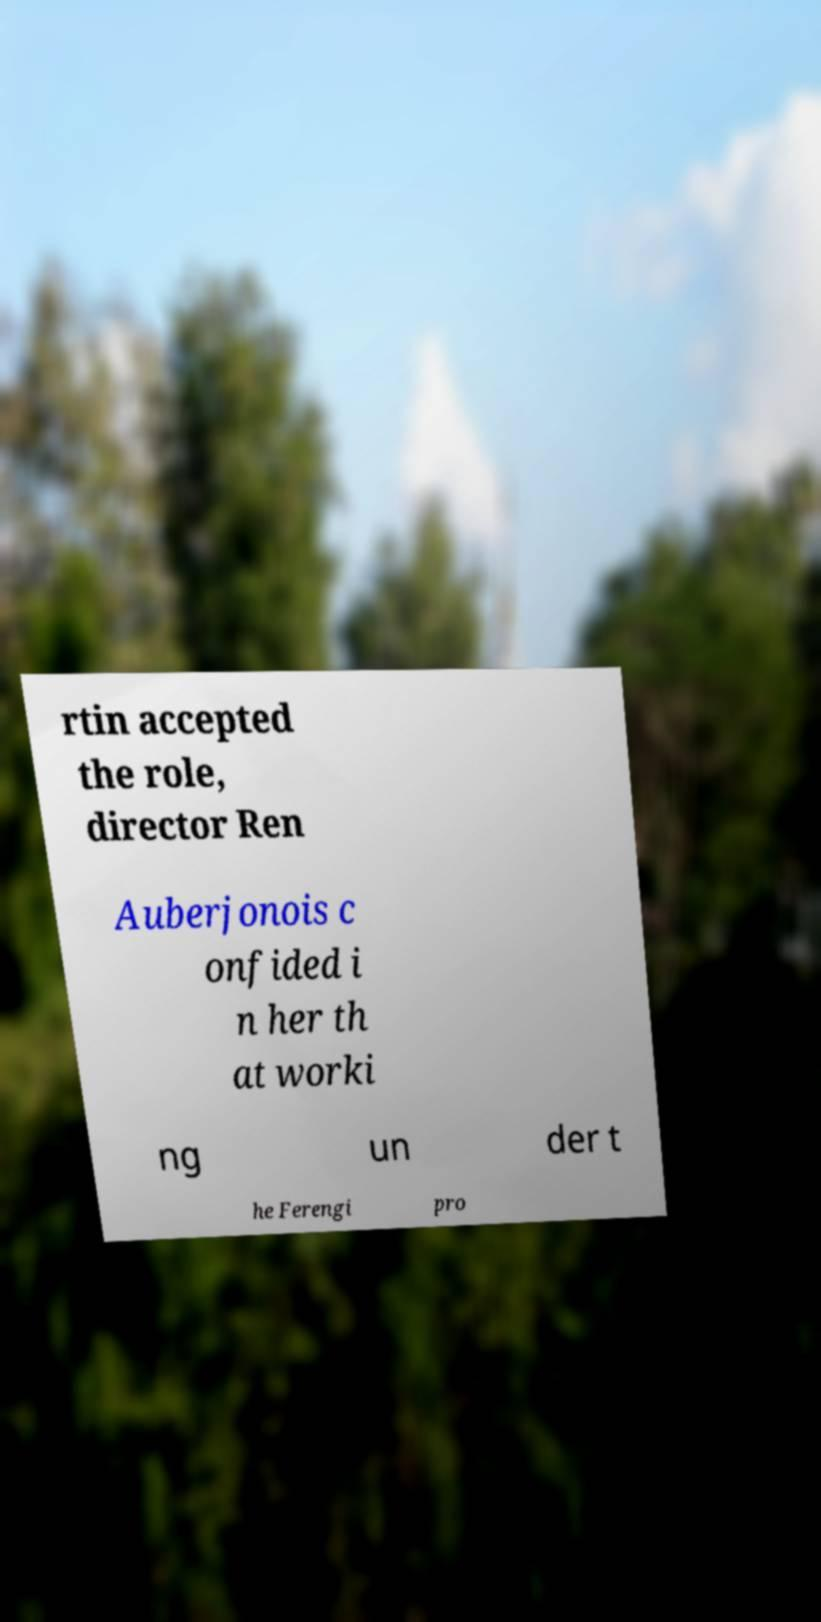Could you extract and type out the text from this image? rtin accepted the role, director Ren Auberjonois c onfided i n her th at worki ng un der t he Ferengi pro 